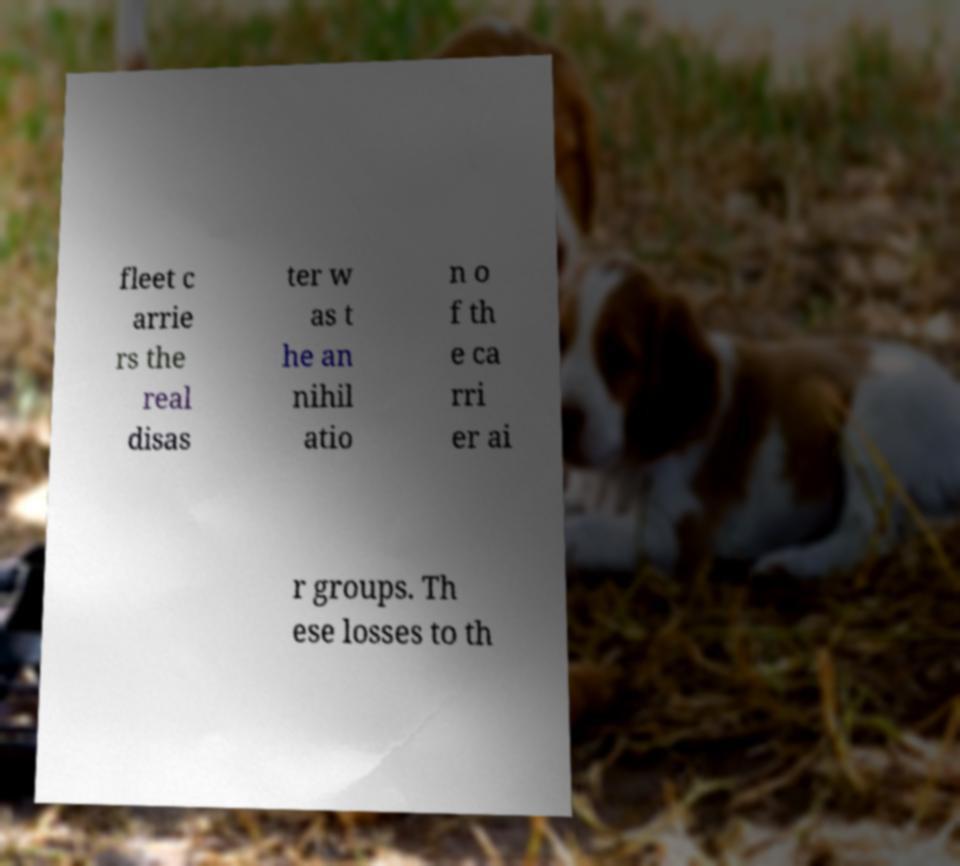Can you read and provide the text displayed in the image?This photo seems to have some interesting text. Can you extract and type it out for me? fleet c arrie rs the real disas ter w as t he an nihil atio n o f th e ca rri er ai r groups. Th ese losses to th 